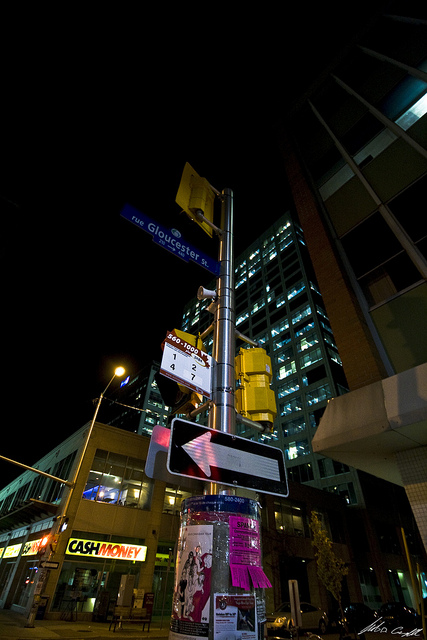Please extract the text content from this image. Gloucester 560-1000 CASHMONEY 7 2 1 